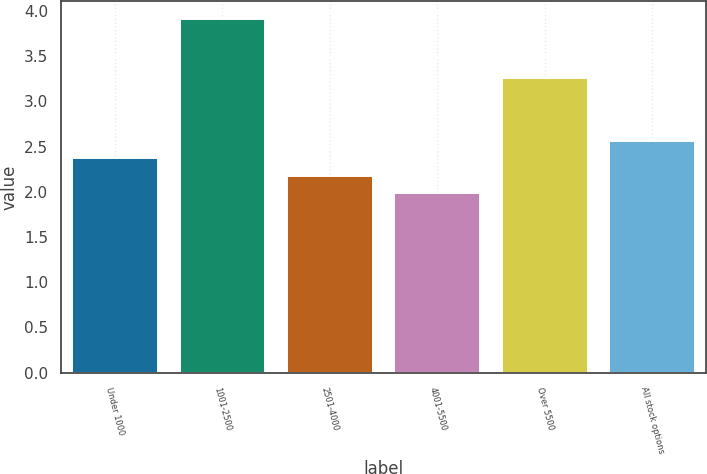<chart> <loc_0><loc_0><loc_500><loc_500><bar_chart><fcel>Under 1000<fcel>1001-2500<fcel>2501-4000<fcel>4001-5500<fcel>Over 5500<fcel>All stock options<nl><fcel>2.37<fcel>3.91<fcel>2.18<fcel>1.99<fcel>3.26<fcel>2.56<nl></chart> 